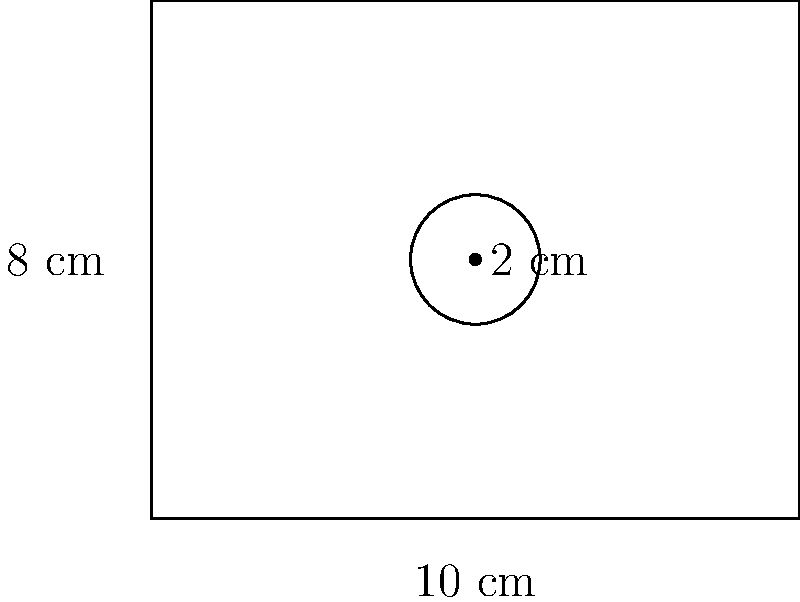You are designing a poster for a psychology research presentation at an international cultural exchange event. The rectangular poster measures 10 cm by 8 cm, with a circular logo in the center. The logo has a diameter of 2 cm. Calculate the area of the poster that is available for presenting your research findings, excluding the area of the logo. To solve this problem, we need to follow these steps:

1. Calculate the total area of the rectangular poster:
   Area of rectangle = length × width
   $A_r = 10 \text{ cm} \times 8 \text{ cm} = 80 \text{ cm}^2$

2. Calculate the area of the circular logo:
   Area of circle = $\pi r^2$, where $r$ is the radius
   Radius = diameter ÷ 2 = 2 cm ÷ 2 = 1 cm
   $A_c = \pi \times (1 \text{ cm})^2 = \pi \text{ cm}^2$

3. Subtract the area of the logo from the total poster area:
   Available area = Total area - Logo area
   $A_{\text{available}} = A_r - A_c = 80 \text{ cm}^2 - \pi \text{ cm}^2$

4. Simplify the expression:
   $A_{\text{available}} = 80 - \pi \text{ cm}^2$
   $A_{\text{available}} \approx 76.86 \text{ cm}^2$ (rounded to two decimal places)

Therefore, the area available for presenting research findings is $80 - \pi \text{ cm}^2$ or approximately 76.86 cm².
Answer: $80 - \pi \text{ cm}^2$ or 76.86 cm² (rounded) 